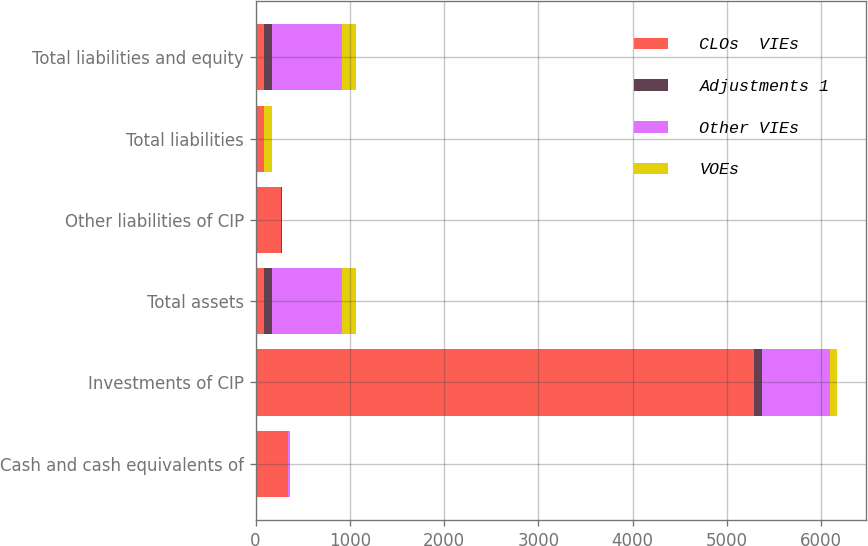Convert chart. <chart><loc_0><loc_0><loc_500><loc_500><stacked_bar_chart><ecel><fcel>Cash and cash equivalents of<fcel>Investments of CIP<fcel>Total assets<fcel>Other liabilities of CIP<fcel>Total liabilities<fcel>Total liabilities and equity<nl><fcel>CLOs  VIEs<fcel>342.1<fcel>5289.5<fcel>85.2<fcel>274.1<fcel>85.2<fcel>85.2<nl><fcel>Adjustments 1<fcel>1.4<fcel>83.7<fcel>85.2<fcel>1.2<fcel>1.2<fcel>85.2<nl><fcel>Other VIEs<fcel>19.4<fcel>719.1<fcel>750.2<fcel>3.4<fcel>3.4<fcel>750.2<nl><fcel>VOEs<fcel>0.4<fcel>76.2<fcel>149.2<fcel>5<fcel>87.2<fcel>149.2<nl></chart> 